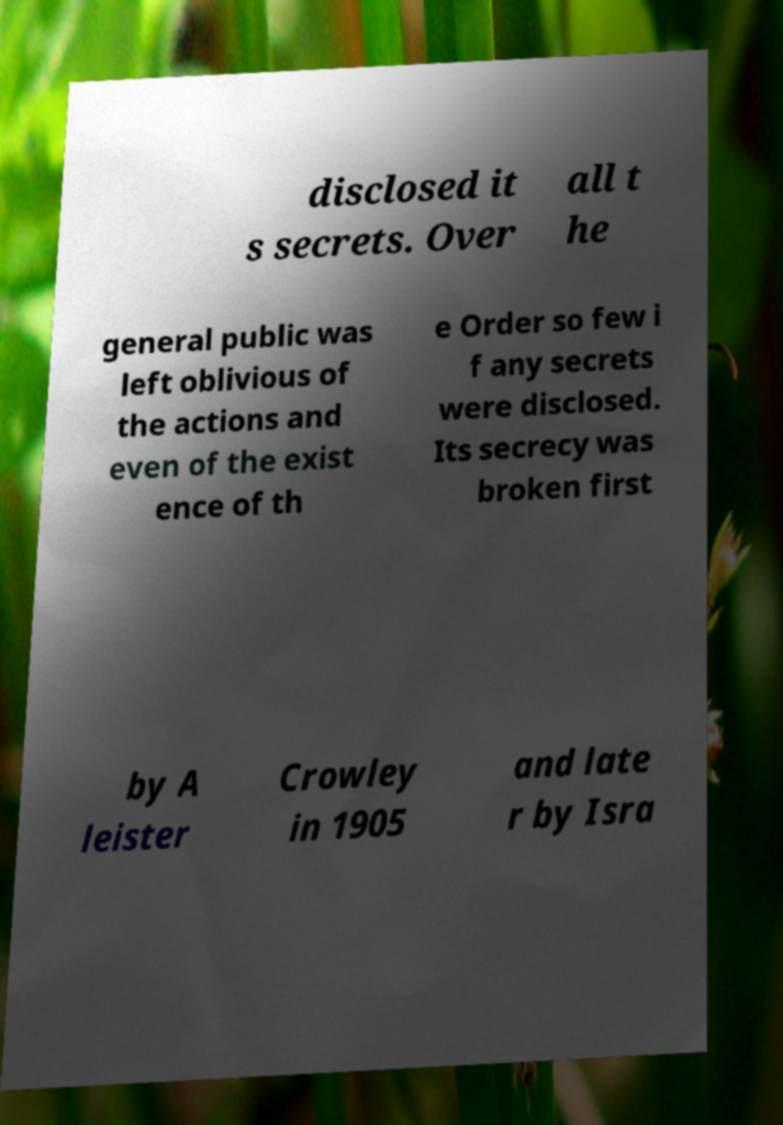For documentation purposes, I need the text within this image transcribed. Could you provide that? disclosed it s secrets. Over all t he general public was left oblivious of the actions and even of the exist ence of th e Order so few i f any secrets were disclosed. Its secrecy was broken first by A leister Crowley in 1905 and late r by Isra 